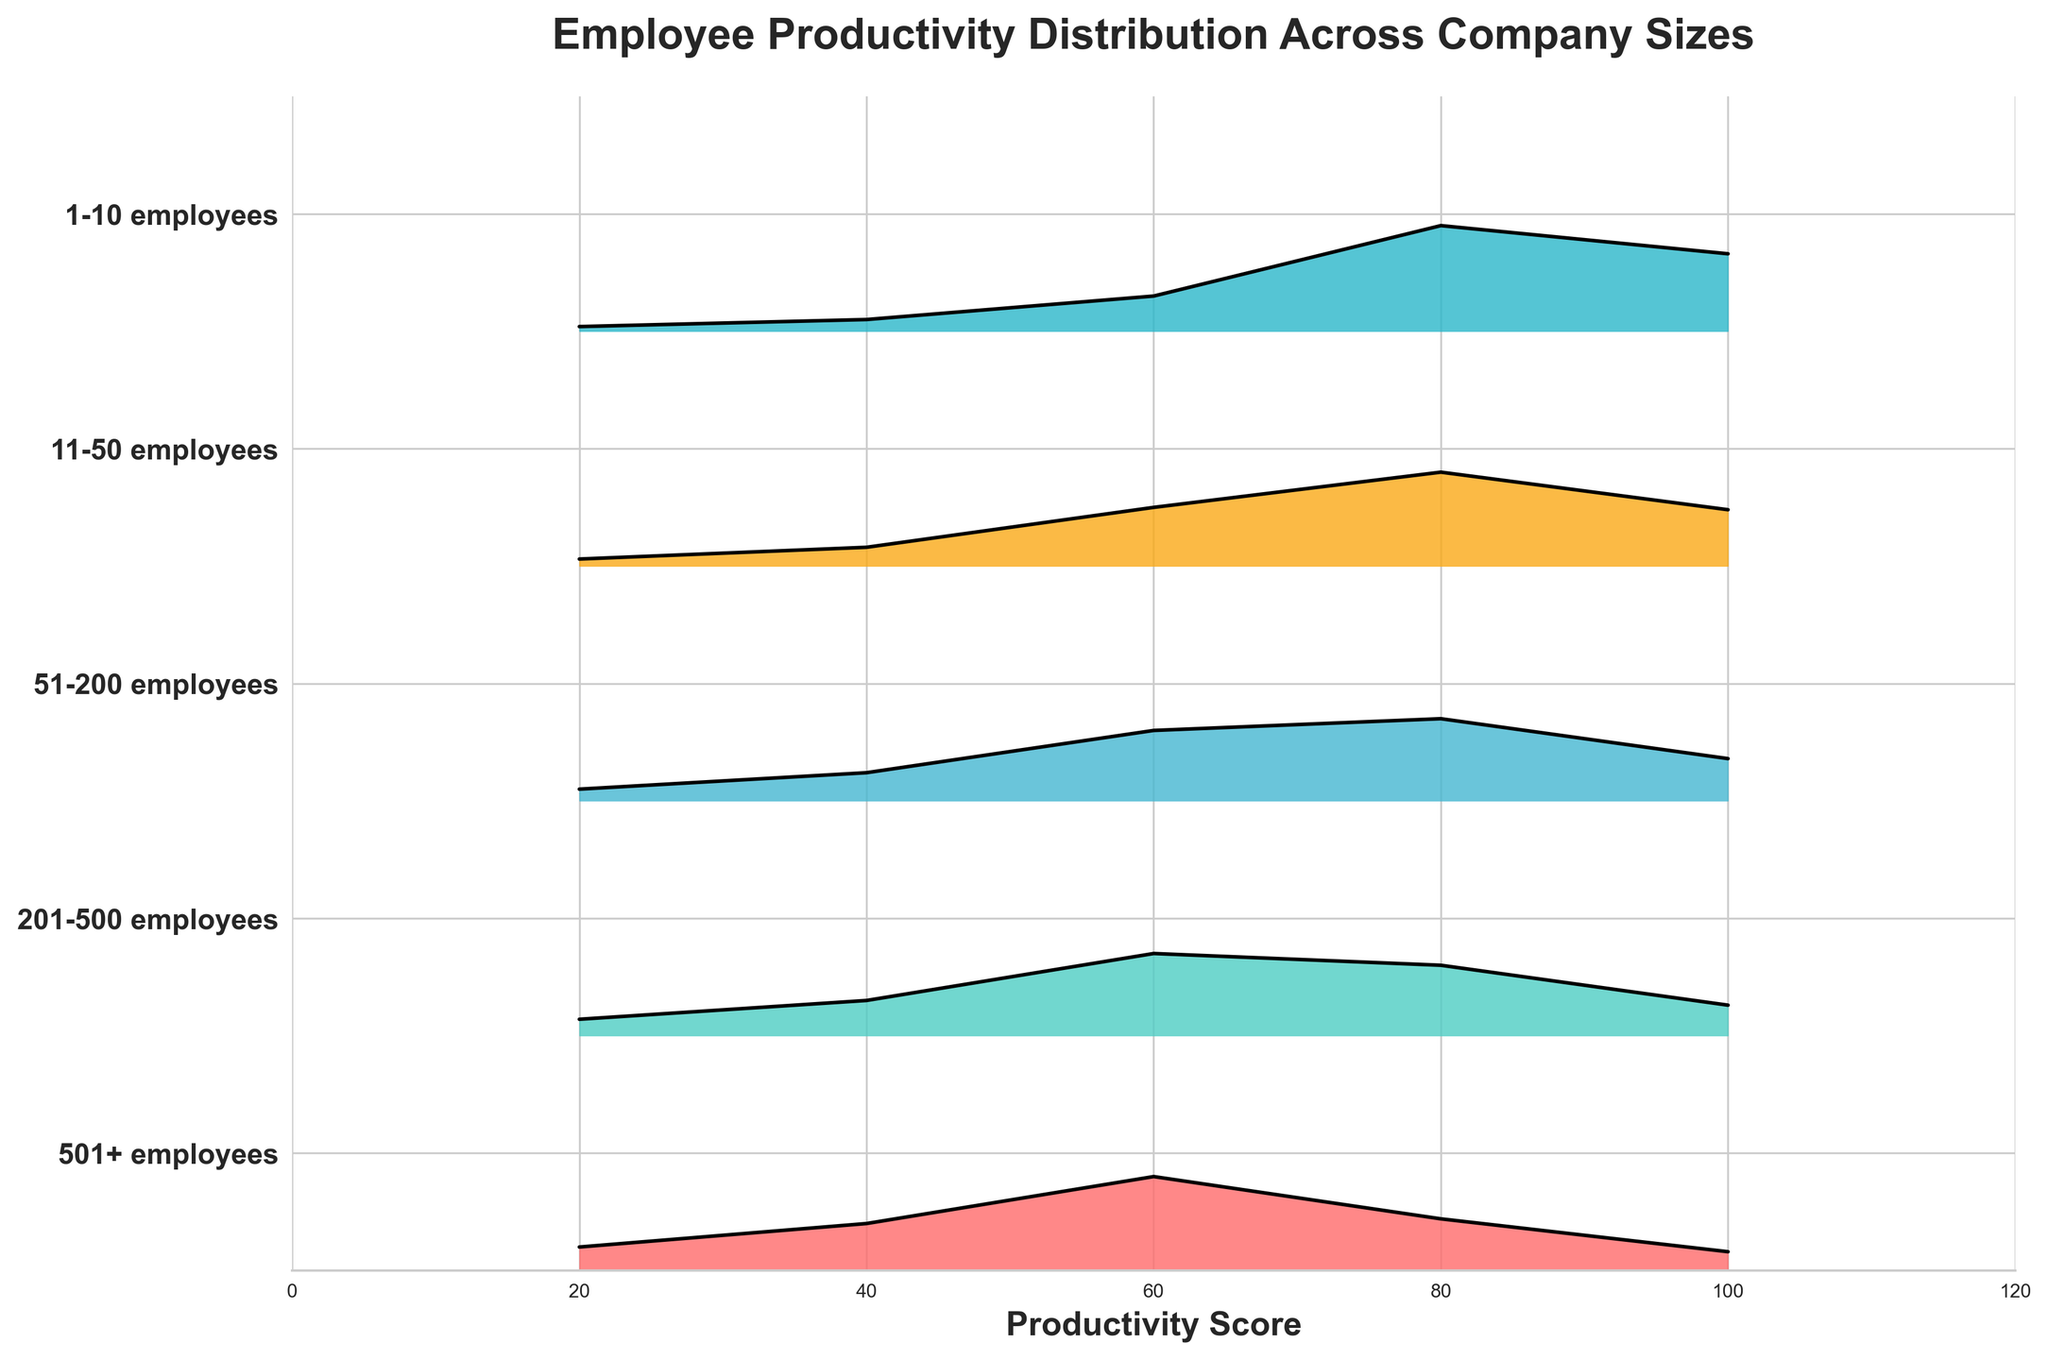What is the title of the figure? The title is located at the top of the figure, typically providing a brief description of what the chart represents. In this case, it describes the content as the distribution of employee productivity across different company sizes.
Answer: Employee Productivity Distribution Across Company Sizes Which company size has the highest productivity frequency for a score of 100? Looking across the Ridgeline plot, observe the frequencies for the productivity score of 100. The company size with the highest visible peak at this productivity score indicates the highest frequency.
Answer: 1-10 employees What is the range of productivity scores displayed on the x-axis? The x-axis shows the productivity scores, which can be seen extending from the lowest to the highest value labeled along the axis.
Answer: 0 to 120 Between which two company sizes does the frequency of productivity scores show a notable decrease for a score of 80? By comparing the peaks at a productivity score of 80 for adjacent company sizes, you can observe any significant decreases in frequency. The notable change indicates where the decrease occurs.
Answer: 51-200 employees and 201-500 employees Which company size has the most diverse distribution of productivity scores? By visually inspecting the spread of productivity scores, the company size with the widest distribution range is the most diverse.
Answer: 501+ employees How does the productivity distribution of companies with 201-500 employees compare to those with 501+ employees? Comparing the overlap and spread of the two distributions shows how the frequencies for each productivity score align, focusing on where one appears more spread out or taller than the other.
Answer: Companies with 501+ employees exhibit a broader and less concentrated distribution What is the most frequent productivity score for companies with 51-200 employees? The highest peak or tallest section in the ridgeline for the specified company size indicates the most frequent productivity score.
Answer: 60 Across all company sizes, which productivity score has the highest combined frequency? By observing the frequencies along the ridgelines collectively, the productivity score with the tallest cumulative frequency across all company sizes can be identified.
Answer: 80 For companies with 11-50 employees, which productivity score shows a sharp increase in frequency compared to the previous score? Identifying the abrupt increase in frequency from one productivity score to the next involves comparing the differences between successive scores.
Answer: 80 